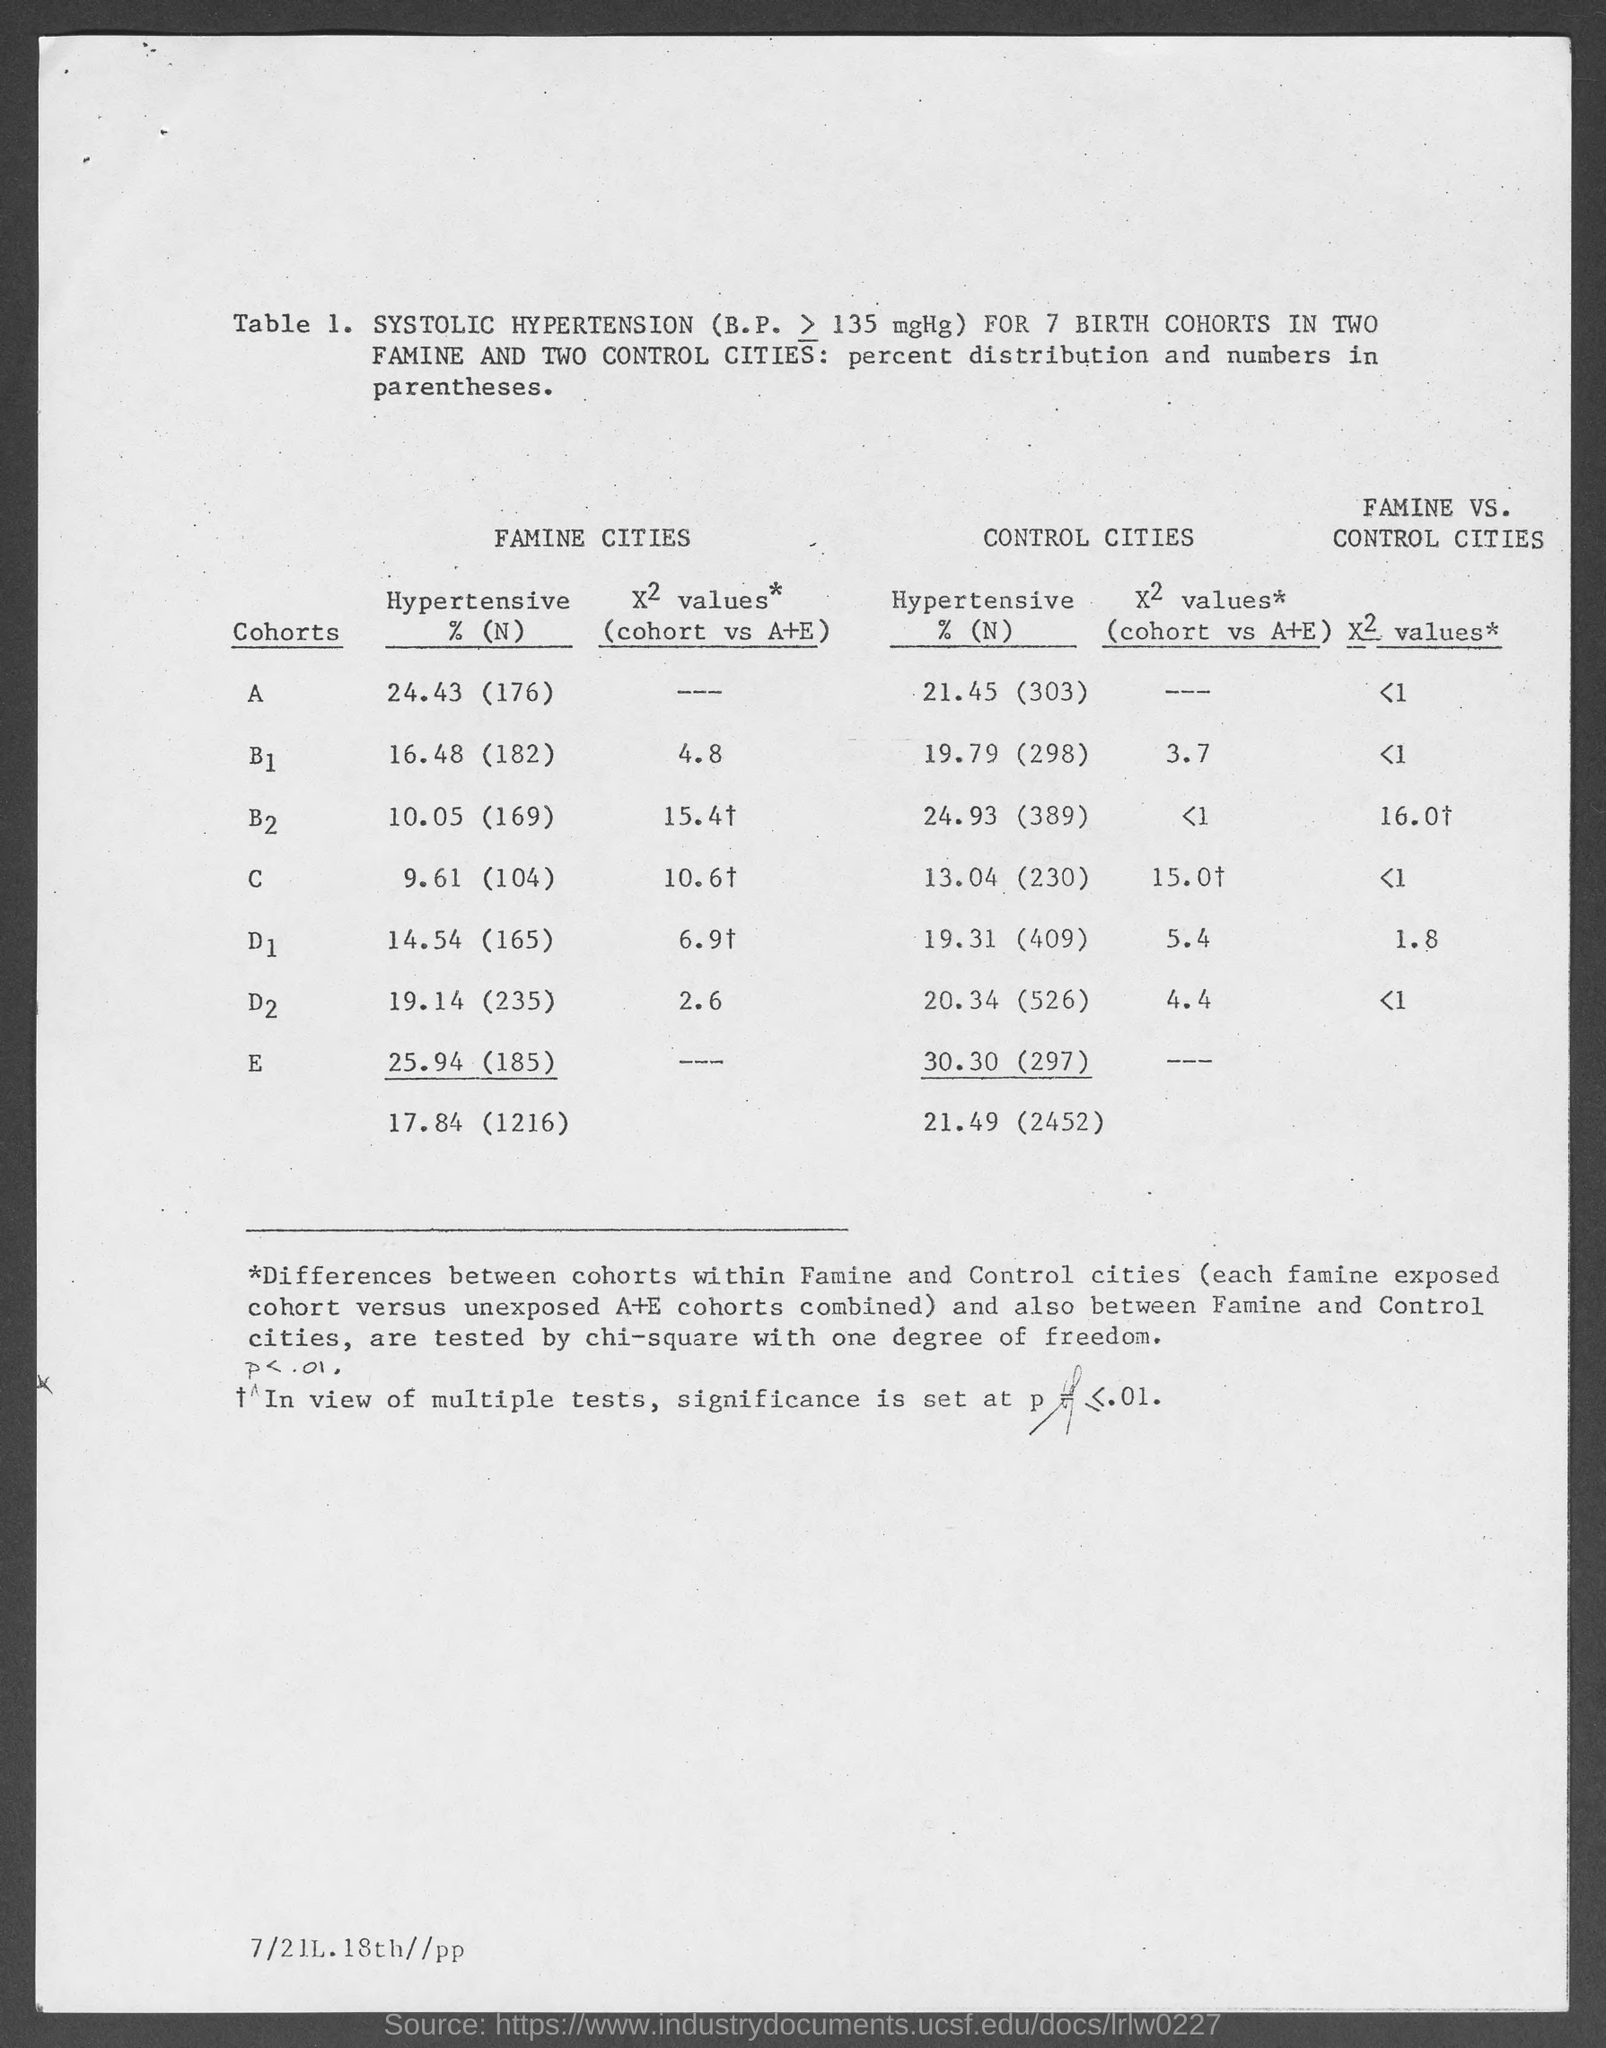Point out several critical features in this image. The hypertensive percentage value for cohorts E in famine cities is 25.94 (185). The hypertensive percentage value for cohort D2 in control cities, as mentioned in the given table, is 20.34 (526). The hypertensive percentage value for cohort B1 in control cities, as mentioned in the given table, is 19.79 (298). The hypertensive percentage value for cohorts D1 in famine cities, as listed in the given table, is 14.54 (165). Our analysis has revealed a hypertensive percentage of 24.43% for cohorts A in famine cities, as depicted in the provided table. 